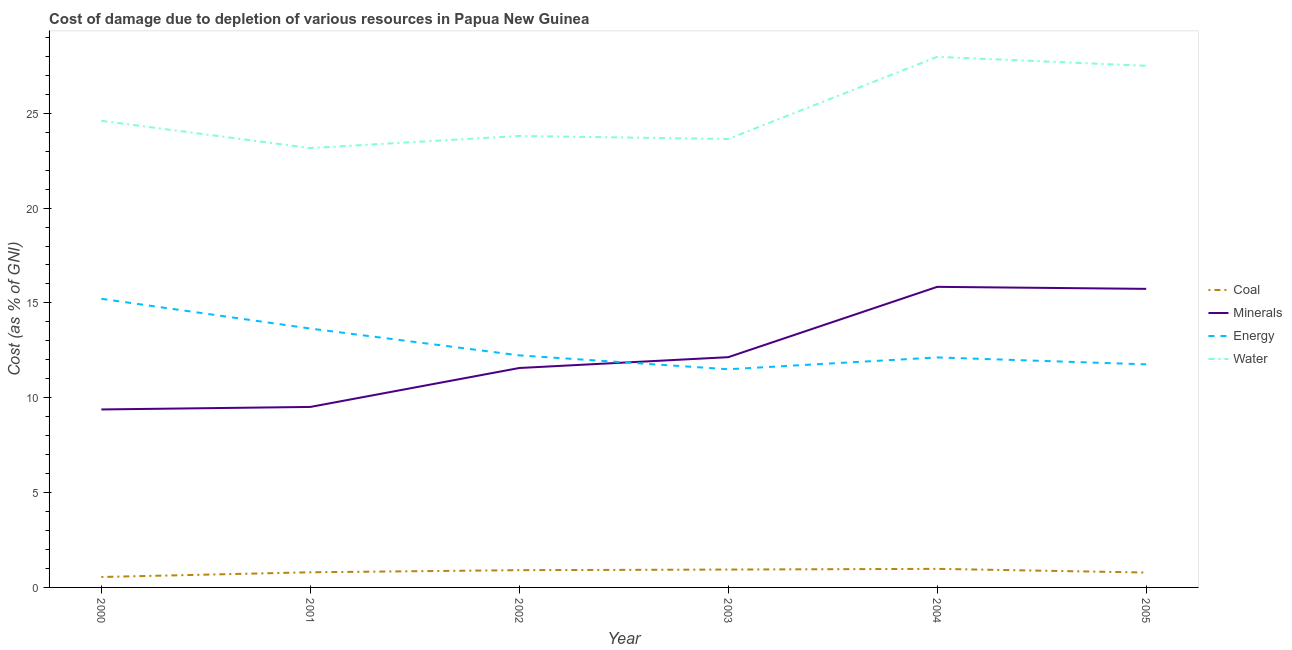How many different coloured lines are there?
Make the answer very short. 4. Is the number of lines equal to the number of legend labels?
Make the answer very short. Yes. What is the cost of damage due to depletion of energy in 2002?
Your answer should be very brief. 12.23. Across all years, what is the maximum cost of damage due to depletion of energy?
Give a very brief answer. 15.22. Across all years, what is the minimum cost of damage due to depletion of minerals?
Your answer should be compact. 9.38. In which year was the cost of damage due to depletion of minerals maximum?
Offer a very short reply. 2004. What is the total cost of damage due to depletion of water in the graph?
Your response must be concise. 150.68. What is the difference between the cost of damage due to depletion of minerals in 2000 and that in 2003?
Offer a very short reply. -2.76. What is the difference between the cost of damage due to depletion of energy in 2002 and the cost of damage due to depletion of minerals in 2005?
Keep it short and to the point. -3.51. What is the average cost of damage due to depletion of coal per year?
Your answer should be compact. 0.83. In the year 2000, what is the difference between the cost of damage due to depletion of minerals and cost of damage due to depletion of water?
Keep it short and to the point. -15.22. In how many years, is the cost of damage due to depletion of coal greater than 28 %?
Give a very brief answer. 0. What is the ratio of the cost of damage due to depletion of water in 2003 to that in 2004?
Keep it short and to the point. 0.85. Is the cost of damage due to depletion of minerals in 2002 less than that in 2004?
Your answer should be compact. Yes. What is the difference between the highest and the second highest cost of damage due to depletion of energy?
Make the answer very short. 1.57. What is the difference between the highest and the lowest cost of damage due to depletion of energy?
Make the answer very short. 3.71. Is it the case that in every year, the sum of the cost of damage due to depletion of coal and cost of damage due to depletion of minerals is greater than the sum of cost of damage due to depletion of energy and cost of damage due to depletion of water?
Provide a short and direct response. Yes. Does the cost of damage due to depletion of minerals monotonically increase over the years?
Provide a succinct answer. No. How many lines are there?
Your response must be concise. 4. What is the difference between two consecutive major ticks on the Y-axis?
Give a very brief answer. 5. Are the values on the major ticks of Y-axis written in scientific E-notation?
Make the answer very short. No. Does the graph contain any zero values?
Ensure brevity in your answer.  No. Where does the legend appear in the graph?
Offer a terse response. Center right. How many legend labels are there?
Offer a very short reply. 4. How are the legend labels stacked?
Your answer should be very brief. Vertical. What is the title of the graph?
Offer a terse response. Cost of damage due to depletion of various resources in Papua New Guinea . Does "Public resource use" appear as one of the legend labels in the graph?
Provide a succinct answer. No. What is the label or title of the Y-axis?
Give a very brief answer. Cost (as % of GNI). What is the Cost (as % of GNI) in Coal in 2000?
Provide a succinct answer. 0.55. What is the Cost (as % of GNI) of Minerals in 2000?
Your answer should be compact. 9.38. What is the Cost (as % of GNI) of Energy in 2000?
Give a very brief answer. 15.22. What is the Cost (as % of GNI) of Water in 2000?
Offer a very short reply. 24.6. What is the Cost (as % of GNI) in Coal in 2001?
Give a very brief answer. 0.8. What is the Cost (as % of GNI) in Minerals in 2001?
Give a very brief answer. 9.52. What is the Cost (as % of GNI) of Energy in 2001?
Keep it short and to the point. 13.65. What is the Cost (as % of GNI) of Water in 2001?
Your answer should be very brief. 23.16. What is the Cost (as % of GNI) in Coal in 2002?
Provide a short and direct response. 0.91. What is the Cost (as % of GNI) of Minerals in 2002?
Offer a terse response. 11.57. What is the Cost (as % of GNI) in Energy in 2002?
Ensure brevity in your answer.  12.23. What is the Cost (as % of GNI) in Water in 2002?
Your answer should be very brief. 23.8. What is the Cost (as % of GNI) in Coal in 2003?
Your response must be concise. 0.94. What is the Cost (as % of GNI) of Minerals in 2003?
Provide a succinct answer. 12.14. What is the Cost (as % of GNI) of Energy in 2003?
Ensure brevity in your answer.  11.5. What is the Cost (as % of GNI) of Water in 2003?
Make the answer very short. 23.64. What is the Cost (as % of GNI) in Coal in 2004?
Make the answer very short. 0.98. What is the Cost (as % of GNI) of Minerals in 2004?
Your response must be concise. 15.85. What is the Cost (as % of GNI) in Energy in 2004?
Keep it short and to the point. 12.13. What is the Cost (as % of GNI) in Water in 2004?
Your answer should be compact. 27.97. What is the Cost (as % of GNI) in Coal in 2005?
Your response must be concise. 0.79. What is the Cost (as % of GNI) of Minerals in 2005?
Offer a terse response. 15.74. What is the Cost (as % of GNI) of Energy in 2005?
Your answer should be compact. 11.76. What is the Cost (as % of GNI) of Water in 2005?
Provide a succinct answer. 27.5. Across all years, what is the maximum Cost (as % of GNI) in Coal?
Your response must be concise. 0.98. Across all years, what is the maximum Cost (as % of GNI) in Minerals?
Offer a terse response. 15.85. Across all years, what is the maximum Cost (as % of GNI) of Energy?
Your response must be concise. 15.22. Across all years, what is the maximum Cost (as % of GNI) in Water?
Your response must be concise. 27.97. Across all years, what is the minimum Cost (as % of GNI) in Coal?
Your answer should be compact. 0.55. Across all years, what is the minimum Cost (as % of GNI) in Minerals?
Offer a very short reply. 9.38. Across all years, what is the minimum Cost (as % of GNI) of Energy?
Provide a succinct answer. 11.5. Across all years, what is the minimum Cost (as % of GNI) of Water?
Provide a succinct answer. 23.16. What is the total Cost (as % of GNI) of Coal in the graph?
Make the answer very short. 4.97. What is the total Cost (as % of GNI) of Minerals in the graph?
Offer a very short reply. 74.19. What is the total Cost (as % of GNI) in Energy in the graph?
Ensure brevity in your answer.  76.49. What is the total Cost (as % of GNI) of Water in the graph?
Give a very brief answer. 150.68. What is the difference between the Cost (as % of GNI) of Coal in 2000 and that in 2001?
Make the answer very short. -0.25. What is the difference between the Cost (as % of GNI) in Minerals in 2000 and that in 2001?
Ensure brevity in your answer.  -0.13. What is the difference between the Cost (as % of GNI) of Energy in 2000 and that in 2001?
Your answer should be very brief. 1.57. What is the difference between the Cost (as % of GNI) of Water in 2000 and that in 2001?
Make the answer very short. 1.44. What is the difference between the Cost (as % of GNI) in Coal in 2000 and that in 2002?
Provide a succinct answer. -0.36. What is the difference between the Cost (as % of GNI) in Minerals in 2000 and that in 2002?
Ensure brevity in your answer.  -2.19. What is the difference between the Cost (as % of GNI) in Energy in 2000 and that in 2002?
Provide a succinct answer. 2.98. What is the difference between the Cost (as % of GNI) in Water in 2000 and that in 2002?
Give a very brief answer. 0.8. What is the difference between the Cost (as % of GNI) of Coal in 2000 and that in 2003?
Offer a very short reply. -0.39. What is the difference between the Cost (as % of GNI) of Minerals in 2000 and that in 2003?
Give a very brief answer. -2.76. What is the difference between the Cost (as % of GNI) in Energy in 2000 and that in 2003?
Ensure brevity in your answer.  3.71. What is the difference between the Cost (as % of GNI) of Water in 2000 and that in 2003?
Offer a terse response. 0.96. What is the difference between the Cost (as % of GNI) of Coal in 2000 and that in 2004?
Offer a terse response. -0.43. What is the difference between the Cost (as % of GNI) of Minerals in 2000 and that in 2004?
Your response must be concise. -6.46. What is the difference between the Cost (as % of GNI) of Energy in 2000 and that in 2004?
Provide a short and direct response. 3.09. What is the difference between the Cost (as % of GNI) of Water in 2000 and that in 2004?
Offer a very short reply. -3.37. What is the difference between the Cost (as % of GNI) of Coal in 2000 and that in 2005?
Your answer should be very brief. -0.24. What is the difference between the Cost (as % of GNI) of Minerals in 2000 and that in 2005?
Your answer should be very brief. -6.36. What is the difference between the Cost (as % of GNI) in Energy in 2000 and that in 2005?
Your answer should be compact. 3.46. What is the difference between the Cost (as % of GNI) in Water in 2000 and that in 2005?
Offer a very short reply. -2.9. What is the difference between the Cost (as % of GNI) in Coal in 2001 and that in 2002?
Offer a very short reply. -0.11. What is the difference between the Cost (as % of GNI) of Minerals in 2001 and that in 2002?
Give a very brief answer. -2.05. What is the difference between the Cost (as % of GNI) of Energy in 2001 and that in 2002?
Your answer should be very brief. 1.41. What is the difference between the Cost (as % of GNI) of Water in 2001 and that in 2002?
Keep it short and to the point. -0.64. What is the difference between the Cost (as % of GNI) in Coal in 2001 and that in 2003?
Offer a very short reply. -0.14. What is the difference between the Cost (as % of GNI) in Minerals in 2001 and that in 2003?
Keep it short and to the point. -2.62. What is the difference between the Cost (as % of GNI) in Energy in 2001 and that in 2003?
Give a very brief answer. 2.15. What is the difference between the Cost (as % of GNI) in Water in 2001 and that in 2003?
Your answer should be very brief. -0.48. What is the difference between the Cost (as % of GNI) in Coal in 2001 and that in 2004?
Your answer should be compact. -0.18. What is the difference between the Cost (as % of GNI) of Minerals in 2001 and that in 2004?
Give a very brief answer. -6.33. What is the difference between the Cost (as % of GNI) in Energy in 2001 and that in 2004?
Your response must be concise. 1.52. What is the difference between the Cost (as % of GNI) of Water in 2001 and that in 2004?
Offer a very short reply. -4.81. What is the difference between the Cost (as % of GNI) of Coal in 2001 and that in 2005?
Provide a short and direct response. 0.01. What is the difference between the Cost (as % of GNI) in Minerals in 2001 and that in 2005?
Provide a short and direct response. -6.23. What is the difference between the Cost (as % of GNI) in Energy in 2001 and that in 2005?
Offer a terse response. 1.89. What is the difference between the Cost (as % of GNI) of Water in 2001 and that in 2005?
Offer a very short reply. -4.34. What is the difference between the Cost (as % of GNI) in Coal in 2002 and that in 2003?
Provide a short and direct response. -0.03. What is the difference between the Cost (as % of GNI) in Minerals in 2002 and that in 2003?
Your answer should be compact. -0.57. What is the difference between the Cost (as % of GNI) of Energy in 2002 and that in 2003?
Ensure brevity in your answer.  0.73. What is the difference between the Cost (as % of GNI) of Water in 2002 and that in 2003?
Provide a short and direct response. 0.16. What is the difference between the Cost (as % of GNI) in Coal in 2002 and that in 2004?
Ensure brevity in your answer.  -0.07. What is the difference between the Cost (as % of GNI) of Minerals in 2002 and that in 2004?
Provide a succinct answer. -4.28. What is the difference between the Cost (as % of GNI) of Energy in 2002 and that in 2004?
Give a very brief answer. 0.11. What is the difference between the Cost (as % of GNI) of Water in 2002 and that in 2004?
Make the answer very short. -4.17. What is the difference between the Cost (as % of GNI) in Coal in 2002 and that in 2005?
Your answer should be compact. 0.13. What is the difference between the Cost (as % of GNI) in Minerals in 2002 and that in 2005?
Offer a terse response. -4.17. What is the difference between the Cost (as % of GNI) in Energy in 2002 and that in 2005?
Your answer should be very brief. 0.47. What is the difference between the Cost (as % of GNI) in Water in 2002 and that in 2005?
Keep it short and to the point. -3.7. What is the difference between the Cost (as % of GNI) of Coal in 2003 and that in 2004?
Offer a terse response. -0.04. What is the difference between the Cost (as % of GNI) of Minerals in 2003 and that in 2004?
Ensure brevity in your answer.  -3.71. What is the difference between the Cost (as % of GNI) of Energy in 2003 and that in 2004?
Make the answer very short. -0.62. What is the difference between the Cost (as % of GNI) of Water in 2003 and that in 2004?
Your answer should be very brief. -4.33. What is the difference between the Cost (as % of GNI) of Coal in 2003 and that in 2005?
Your answer should be very brief. 0.16. What is the difference between the Cost (as % of GNI) of Minerals in 2003 and that in 2005?
Your answer should be very brief. -3.6. What is the difference between the Cost (as % of GNI) of Energy in 2003 and that in 2005?
Your response must be concise. -0.26. What is the difference between the Cost (as % of GNI) of Water in 2003 and that in 2005?
Provide a short and direct response. -3.86. What is the difference between the Cost (as % of GNI) in Coal in 2004 and that in 2005?
Provide a succinct answer. 0.19. What is the difference between the Cost (as % of GNI) of Minerals in 2004 and that in 2005?
Ensure brevity in your answer.  0.11. What is the difference between the Cost (as % of GNI) of Energy in 2004 and that in 2005?
Offer a terse response. 0.37. What is the difference between the Cost (as % of GNI) of Water in 2004 and that in 2005?
Provide a short and direct response. 0.47. What is the difference between the Cost (as % of GNI) of Coal in 2000 and the Cost (as % of GNI) of Minerals in 2001?
Ensure brevity in your answer.  -8.97. What is the difference between the Cost (as % of GNI) in Coal in 2000 and the Cost (as % of GNI) in Energy in 2001?
Your response must be concise. -13.1. What is the difference between the Cost (as % of GNI) of Coal in 2000 and the Cost (as % of GNI) of Water in 2001?
Provide a succinct answer. -22.61. What is the difference between the Cost (as % of GNI) of Minerals in 2000 and the Cost (as % of GNI) of Energy in 2001?
Your answer should be compact. -4.27. What is the difference between the Cost (as % of GNI) in Minerals in 2000 and the Cost (as % of GNI) in Water in 2001?
Keep it short and to the point. -13.78. What is the difference between the Cost (as % of GNI) of Energy in 2000 and the Cost (as % of GNI) of Water in 2001?
Make the answer very short. -7.95. What is the difference between the Cost (as % of GNI) in Coal in 2000 and the Cost (as % of GNI) in Minerals in 2002?
Give a very brief answer. -11.02. What is the difference between the Cost (as % of GNI) of Coal in 2000 and the Cost (as % of GNI) of Energy in 2002?
Your answer should be very brief. -11.68. What is the difference between the Cost (as % of GNI) of Coal in 2000 and the Cost (as % of GNI) of Water in 2002?
Make the answer very short. -23.25. What is the difference between the Cost (as % of GNI) in Minerals in 2000 and the Cost (as % of GNI) in Energy in 2002?
Make the answer very short. -2.85. What is the difference between the Cost (as % of GNI) in Minerals in 2000 and the Cost (as % of GNI) in Water in 2002?
Give a very brief answer. -14.42. What is the difference between the Cost (as % of GNI) of Energy in 2000 and the Cost (as % of GNI) of Water in 2002?
Offer a terse response. -8.59. What is the difference between the Cost (as % of GNI) in Coal in 2000 and the Cost (as % of GNI) in Minerals in 2003?
Offer a terse response. -11.59. What is the difference between the Cost (as % of GNI) of Coal in 2000 and the Cost (as % of GNI) of Energy in 2003?
Your response must be concise. -10.95. What is the difference between the Cost (as % of GNI) in Coal in 2000 and the Cost (as % of GNI) in Water in 2003?
Provide a succinct answer. -23.09. What is the difference between the Cost (as % of GNI) of Minerals in 2000 and the Cost (as % of GNI) of Energy in 2003?
Offer a terse response. -2.12. What is the difference between the Cost (as % of GNI) in Minerals in 2000 and the Cost (as % of GNI) in Water in 2003?
Offer a terse response. -14.26. What is the difference between the Cost (as % of GNI) in Energy in 2000 and the Cost (as % of GNI) in Water in 2003?
Keep it short and to the point. -8.42. What is the difference between the Cost (as % of GNI) in Coal in 2000 and the Cost (as % of GNI) in Minerals in 2004?
Your response must be concise. -15.3. What is the difference between the Cost (as % of GNI) of Coal in 2000 and the Cost (as % of GNI) of Energy in 2004?
Your response must be concise. -11.58. What is the difference between the Cost (as % of GNI) in Coal in 2000 and the Cost (as % of GNI) in Water in 2004?
Your answer should be compact. -27.42. What is the difference between the Cost (as % of GNI) in Minerals in 2000 and the Cost (as % of GNI) in Energy in 2004?
Offer a very short reply. -2.74. What is the difference between the Cost (as % of GNI) in Minerals in 2000 and the Cost (as % of GNI) in Water in 2004?
Make the answer very short. -18.59. What is the difference between the Cost (as % of GNI) of Energy in 2000 and the Cost (as % of GNI) of Water in 2004?
Ensure brevity in your answer.  -12.76. What is the difference between the Cost (as % of GNI) in Coal in 2000 and the Cost (as % of GNI) in Minerals in 2005?
Ensure brevity in your answer.  -15.19. What is the difference between the Cost (as % of GNI) of Coal in 2000 and the Cost (as % of GNI) of Energy in 2005?
Ensure brevity in your answer.  -11.21. What is the difference between the Cost (as % of GNI) in Coal in 2000 and the Cost (as % of GNI) in Water in 2005?
Provide a succinct answer. -26.95. What is the difference between the Cost (as % of GNI) of Minerals in 2000 and the Cost (as % of GNI) of Energy in 2005?
Provide a succinct answer. -2.38. What is the difference between the Cost (as % of GNI) of Minerals in 2000 and the Cost (as % of GNI) of Water in 2005?
Your answer should be very brief. -18.12. What is the difference between the Cost (as % of GNI) in Energy in 2000 and the Cost (as % of GNI) in Water in 2005?
Give a very brief answer. -12.28. What is the difference between the Cost (as % of GNI) in Coal in 2001 and the Cost (as % of GNI) in Minerals in 2002?
Your response must be concise. -10.77. What is the difference between the Cost (as % of GNI) in Coal in 2001 and the Cost (as % of GNI) in Energy in 2002?
Provide a succinct answer. -11.44. What is the difference between the Cost (as % of GNI) of Coal in 2001 and the Cost (as % of GNI) of Water in 2002?
Provide a succinct answer. -23. What is the difference between the Cost (as % of GNI) of Minerals in 2001 and the Cost (as % of GNI) of Energy in 2002?
Provide a short and direct response. -2.72. What is the difference between the Cost (as % of GNI) of Minerals in 2001 and the Cost (as % of GNI) of Water in 2002?
Offer a very short reply. -14.29. What is the difference between the Cost (as % of GNI) in Energy in 2001 and the Cost (as % of GNI) in Water in 2002?
Your answer should be very brief. -10.15. What is the difference between the Cost (as % of GNI) of Coal in 2001 and the Cost (as % of GNI) of Minerals in 2003?
Your answer should be compact. -11.34. What is the difference between the Cost (as % of GNI) in Coal in 2001 and the Cost (as % of GNI) in Energy in 2003?
Provide a short and direct response. -10.7. What is the difference between the Cost (as % of GNI) in Coal in 2001 and the Cost (as % of GNI) in Water in 2003?
Ensure brevity in your answer.  -22.84. What is the difference between the Cost (as % of GNI) of Minerals in 2001 and the Cost (as % of GNI) of Energy in 2003?
Give a very brief answer. -1.99. What is the difference between the Cost (as % of GNI) of Minerals in 2001 and the Cost (as % of GNI) of Water in 2003?
Your answer should be very brief. -14.13. What is the difference between the Cost (as % of GNI) of Energy in 2001 and the Cost (as % of GNI) of Water in 2003?
Provide a succinct answer. -9.99. What is the difference between the Cost (as % of GNI) of Coal in 2001 and the Cost (as % of GNI) of Minerals in 2004?
Offer a terse response. -15.05. What is the difference between the Cost (as % of GNI) in Coal in 2001 and the Cost (as % of GNI) in Energy in 2004?
Provide a succinct answer. -11.33. What is the difference between the Cost (as % of GNI) in Coal in 2001 and the Cost (as % of GNI) in Water in 2004?
Provide a succinct answer. -27.18. What is the difference between the Cost (as % of GNI) in Minerals in 2001 and the Cost (as % of GNI) in Energy in 2004?
Give a very brief answer. -2.61. What is the difference between the Cost (as % of GNI) of Minerals in 2001 and the Cost (as % of GNI) of Water in 2004?
Your answer should be compact. -18.46. What is the difference between the Cost (as % of GNI) in Energy in 2001 and the Cost (as % of GNI) in Water in 2004?
Keep it short and to the point. -14.33. What is the difference between the Cost (as % of GNI) in Coal in 2001 and the Cost (as % of GNI) in Minerals in 2005?
Offer a very short reply. -14.94. What is the difference between the Cost (as % of GNI) in Coal in 2001 and the Cost (as % of GNI) in Energy in 2005?
Provide a short and direct response. -10.96. What is the difference between the Cost (as % of GNI) in Coal in 2001 and the Cost (as % of GNI) in Water in 2005?
Keep it short and to the point. -26.7. What is the difference between the Cost (as % of GNI) of Minerals in 2001 and the Cost (as % of GNI) of Energy in 2005?
Keep it short and to the point. -2.24. What is the difference between the Cost (as % of GNI) in Minerals in 2001 and the Cost (as % of GNI) in Water in 2005?
Offer a terse response. -17.99. What is the difference between the Cost (as % of GNI) in Energy in 2001 and the Cost (as % of GNI) in Water in 2005?
Keep it short and to the point. -13.85. What is the difference between the Cost (as % of GNI) in Coal in 2002 and the Cost (as % of GNI) in Minerals in 2003?
Provide a short and direct response. -11.23. What is the difference between the Cost (as % of GNI) of Coal in 2002 and the Cost (as % of GNI) of Energy in 2003?
Your answer should be compact. -10.59. What is the difference between the Cost (as % of GNI) of Coal in 2002 and the Cost (as % of GNI) of Water in 2003?
Offer a very short reply. -22.73. What is the difference between the Cost (as % of GNI) in Minerals in 2002 and the Cost (as % of GNI) in Energy in 2003?
Offer a very short reply. 0.07. What is the difference between the Cost (as % of GNI) in Minerals in 2002 and the Cost (as % of GNI) in Water in 2003?
Give a very brief answer. -12.07. What is the difference between the Cost (as % of GNI) in Energy in 2002 and the Cost (as % of GNI) in Water in 2003?
Offer a very short reply. -11.41. What is the difference between the Cost (as % of GNI) of Coal in 2002 and the Cost (as % of GNI) of Minerals in 2004?
Provide a succinct answer. -14.94. What is the difference between the Cost (as % of GNI) of Coal in 2002 and the Cost (as % of GNI) of Energy in 2004?
Keep it short and to the point. -11.22. What is the difference between the Cost (as % of GNI) of Coal in 2002 and the Cost (as % of GNI) of Water in 2004?
Make the answer very short. -27.06. What is the difference between the Cost (as % of GNI) of Minerals in 2002 and the Cost (as % of GNI) of Energy in 2004?
Provide a succinct answer. -0.56. What is the difference between the Cost (as % of GNI) in Minerals in 2002 and the Cost (as % of GNI) in Water in 2004?
Provide a short and direct response. -16.41. What is the difference between the Cost (as % of GNI) of Energy in 2002 and the Cost (as % of GNI) of Water in 2004?
Offer a terse response. -15.74. What is the difference between the Cost (as % of GNI) in Coal in 2002 and the Cost (as % of GNI) in Minerals in 2005?
Provide a succinct answer. -14.83. What is the difference between the Cost (as % of GNI) in Coal in 2002 and the Cost (as % of GNI) in Energy in 2005?
Offer a very short reply. -10.85. What is the difference between the Cost (as % of GNI) in Coal in 2002 and the Cost (as % of GNI) in Water in 2005?
Provide a short and direct response. -26.59. What is the difference between the Cost (as % of GNI) of Minerals in 2002 and the Cost (as % of GNI) of Energy in 2005?
Ensure brevity in your answer.  -0.19. What is the difference between the Cost (as % of GNI) of Minerals in 2002 and the Cost (as % of GNI) of Water in 2005?
Your response must be concise. -15.93. What is the difference between the Cost (as % of GNI) in Energy in 2002 and the Cost (as % of GNI) in Water in 2005?
Ensure brevity in your answer.  -15.27. What is the difference between the Cost (as % of GNI) in Coal in 2003 and the Cost (as % of GNI) in Minerals in 2004?
Your answer should be compact. -14.91. What is the difference between the Cost (as % of GNI) in Coal in 2003 and the Cost (as % of GNI) in Energy in 2004?
Your answer should be compact. -11.18. What is the difference between the Cost (as % of GNI) in Coal in 2003 and the Cost (as % of GNI) in Water in 2004?
Make the answer very short. -27.03. What is the difference between the Cost (as % of GNI) in Minerals in 2003 and the Cost (as % of GNI) in Energy in 2004?
Your answer should be compact. 0.01. What is the difference between the Cost (as % of GNI) in Minerals in 2003 and the Cost (as % of GNI) in Water in 2004?
Make the answer very short. -15.83. What is the difference between the Cost (as % of GNI) in Energy in 2003 and the Cost (as % of GNI) in Water in 2004?
Your answer should be very brief. -16.47. What is the difference between the Cost (as % of GNI) of Coal in 2003 and the Cost (as % of GNI) of Minerals in 2005?
Your answer should be compact. -14.8. What is the difference between the Cost (as % of GNI) in Coal in 2003 and the Cost (as % of GNI) in Energy in 2005?
Make the answer very short. -10.82. What is the difference between the Cost (as % of GNI) in Coal in 2003 and the Cost (as % of GNI) in Water in 2005?
Provide a succinct answer. -26.56. What is the difference between the Cost (as % of GNI) in Minerals in 2003 and the Cost (as % of GNI) in Energy in 2005?
Give a very brief answer. 0.38. What is the difference between the Cost (as % of GNI) in Minerals in 2003 and the Cost (as % of GNI) in Water in 2005?
Provide a succinct answer. -15.36. What is the difference between the Cost (as % of GNI) of Energy in 2003 and the Cost (as % of GNI) of Water in 2005?
Your answer should be very brief. -16. What is the difference between the Cost (as % of GNI) in Coal in 2004 and the Cost (as % of GNI) in Minerals in 2005?
Ensure brevity in your answer.  -14.76. What is the difference between the Cost (as % of GNI) of Coal in 2004 and the Cost (as % of GNI) of Energy in 2005?
Your answer should be compact. -10.78. What is the difference between the Cost (as % of GNI) in Coal in 2004 and the Cost (as % of GNI) in Water in 2005?
Offer a terse response. -26.52. What is the difference between the Cost (as % of GNI) in Minerals in 2004 and the Cost (as % of GNI) in Energy in 2005?
Offer a very short reply. 4.09. What is the difference between the Cost (as % of GNI) of Minerals in 2004 and the Cost (as % of GNI) of Water in 2005?
Give a very brief answer. -11.65. What is the difference between the Cost (as % of GNI) of Energy in 2004 and the Cost (as % of GNI) of Water in 2005?
Provide a succinct answer. -15.37. What is the average Cost (as % of GNI) of Coal per year?
Give a very brief answer. 0.83. What is the average Cost (as % of GNI) in Minerals per year?
Your answer should be very brief. 12.37. What is the average Cost (as % of GNI) of Energy per year?
Provide a succinct answer. 12.75. What is the average Cost (as % of GNI) of Water per year?
Ensure brevity in your answer.  25.11. In the year 2000, what is the difference between the Cost (as % of GNI) of Coal and Cost (as % of GNI) of Minerals?
Provide a short and direct response. -8.83. In the year 2000, what is the difference between the Cost (as % of GNI) in Coal and Cost (as % of GNI) in Energy?
Your answer should be compact. -14.67. In the year 2000, what is the difference between the Cost (as % of GNI) of Coal and Cost (as % of GNI) of Water?
Your answer should be compact. -24.05. In the year 2000, what is the difference between the Cost (as % of GNI) in Minerals and Cost (as % of GNI) in Energy?
Offer a terse response. -5.83. In the year 2000, what is the difference between the Cost (as % of GNI) in Minerals and Cost (as % of GNI) in Water?
Offer a very short reply. -15.22. In the year 2000, what is the difference between the Cost (as % of GNI) of Energy and Cost (as % of GNI) of Water?
Make the answer very short. -9.38. In the year 2001, what is the difference between the Cost (as % of GNI) of Coal and Cost (as % of GNI) of Minerals?
Make the answer very short. -8.72. In the year 2001, what is the difference between the Cost (as % of GNI) of Coal and Cost (as % of GNI) of Energy?
Ensure brevity in your answer.  -12.85. In the year 2001, what is the difference between the Cost (as % of GNI) in Coal and Cost (as % of GNI) in Water?
Offer a very short reply. -22.37. In the year 2001, what is the difference between the Cost (as % of GNI) in Minerals and Cost (as % of GNI) in Energy?
Your answer should be very brief. -4.13. In the year 2001, what is the difference between the Cost (as % of GNI) of Minerals and Cost (as % of GNI) of Water?
Provide a succinct answer. -13.65. In the year 2001, what is the difference between the Cost (as % of GNI) in Energy and Cost (as % of GNI) in Water?
Your answer should be very brief. -9.52. In the year 2002, what is the difference between the Cost (as % of GNI) of Coal and Cost (as % of GNI) of Minerals?
Your answer should be compact. -10.66. In the year 2002, what is the difference between the Cost (as % of GNI) in Coal and Cost (as % of GNI) in Energy?
Make the answer very short. -11.32. In the year 2002, what is the difference between the Cost (as % of GNI) in Coal and Cost (as % of GNI) in Water?
Make the answer very short. -22.89. In the year 2002, what is the difference between the Cost (as % of GNI) in Minerals and Cost (as % of GNI) in Energy?
Your response must be concise. -0.67. In the year 2002, what is the difference between the Cost (as % of GNI) in Minerals and Cost (as % of GNI) in Water?
Provide a succinct answer. -12.23. In the year 2002, what is the difference between the Cost (as % of GNI) in Energy and Cost (as % of GNI) in Water?
Your response must be concise. -11.57. In the year 2003, what is the difference between the Cost (as % of GNI) of Coal and Cost (as % of GNI) of Minerals?
Your answer should be compact. -11.2. In the year 2003, what is the difference between the Cost (as % of GNI) of Coal and Cost (as % of GNI) of Energy?
Your answer should be very brief. -10.56. In the year 2003, what is the difference between the Cost (as % of GNI) in Coal and Cost (as % of GNI) in Water?
Your answer should be very brief. -22.7. In the year 2003, what is the difference between the Cost (as % of GNI) in Minerals and Cost (as % of GNI) in Energy?
Your response must be concise. 0.64. In the year 2003, what is the difference between the Cost (as % of GNI) of Minerals and Cost (as % of GNI) of Water?
Ensure brevity in your answer.  -11.5. In the year 2003, what is the difference between the Cost (as % of GNI) of Energy and Cost (as % of GNI) of Water?
Offer a terse response. -12.14. In the year 2004, what is the difference between the Cost (as % of GNI) of Coal and Cost (as % of GNI) of Minerals?
Offer a very short reply. -14.87. In the year 2004, what is the difference between the Cost (as % of GNI) of Coal and Cost (as % of GNI) of Energy?
Ensure brevity in your answer.  -11.15. In the year 2004, what is the difference between the Cost (as % of GNI) in Coal and Cost (as % of GNI) in Water?
Keep it short and to the point. -26.99. In the year 2004, what is the difference between the Cost (as % of GNI) in Minerals and Cost (as % of GNI) in Energy?
Your answer should be very brief. 3.72. In the year 2004, what is the difference between the Cost (as % of GNI) in Minerals and Cost (as % of GNI) in Water?
Make the answer very short. -12.13. In the year 2004, what is the difference between the Cost (as % of GNI) in Energy and Cost (as % of GNI) in Water?
Keep it short and to the point. -15.85. In the year 2005, what is the difference between the Cost (as % of GNI) in Coal and Cost (as % of GNI) in Minerals?
Offer a very short reply. -14.96. In the year 2005, what is the difference between the Cost (as % of GNI) in Coal and Cost (as % of GNI) in Energy?
Provide a short and direct response. -10.97. In the year 2005, what is the difference between the Cost (as % of GNI) of Coal and Cost (as % of GNI) of Water?
Your answer should be very brief. -26.72. In the year 2005, what is the difference between the Cost (as % of GNI) in Minerals and Cost (as % of GNI) in Energy?
Ensure brevity in your answer.  3.98. In the year 2005, what is the difference between the Cost (as % of GNI) of Minerals and Cost (as % of GNI) of Water?
Your answer should be compact. -11.76. In the year 2005, what is the difference between the Cost (as % of GNI) of Energy and Cost (as % of GNI) of Water?
Keep it short and to the point. -15.74. What is the ratio of the Cost (as % of GNI) in Coal in 2000 to that in 2001?
Offer a terse response. 0.69. What is the ratio of the Cost (as % of GNI) of Minerals in 2000 to that in 2001?
Your response must be concise. 0.99. What is the ratio of the Cost (as % of GNI) in Energy in 2000 to that in 2001?
Give a very brief answer. 1.11. What is the ratio of the Cost (as % of GNI) in Water in 2000 to that in 2001?
Make the answer very short. 1.06. What is the ratio of the Cost (as % of GNI) in Coal in 2000 to that in 2002?
Offer a very short reply. 0.6. What is the ratio of the Cost (as % of GNI) in Minerals in 2000 to that in 2002?
Make the answer very short. 0.81. What is the ratio of the Cost (as % of GNI) of Energy in 2000 to that in 2002?
Your answer should be very brief. 1.24. What is the ratio of the Cost (as % of GNI) of Water in 2000 to that in 2002?
Offer a terse response. 1.03. What is the ratio of the Cost (as % of GNI) of Coal in 2000 to that in 2003?
Make the answer very short. 0.58. What is the ratio of the Cost (as % of GNI) in Minerals in 2000 to that in 2003?
Your answer should be compact. 0.77. What is the ratio of the Cost (as % of GNI) in Energy in 2000 to that in 2003?
Give a very brief answer. 1.32. What is the ratio of the Cost (as % of GNI) in Water in 2000 to that in 2003?
Give a very brief answer. 1.04. What is the ratio of the Cost (as % of GNI) of Coal in 2000 to that in 2004?
Offer a very short reply. 0.56. What is the ratio of the Cost (as % of GNI) of Minerals in 2000 to that in 2004?
Ensure brevity in your answer.  0.59. What is the ratio of the Cost (as % of GNI) in Energy in 2000 to that in 2004?
Give a very brief answer. 1.25. What is the ratio of the Cost (as % of GNI) in Water in 2000 to that in 2004?
Keep it short and to the point. 0.88. What is the ratio of the Cost (as % of GNI) of Coal in 2000 to that in 2005?
Your response must be concise. 0.7. What is the ratio of the Cost (as % of GNI) in Minerals in 2000 to that in 2005?
Your answer should be compact. 0.6. What is the ratio of the Cost (as % of GNI) in Energy in 2000 to that in 2005?
Keep it short and to the point. 1.29. What is the ratio of the Cost (as % of GNI) of Water in 2000 to that in 2005?
Ensure brevity in your answer.  0.89. What is the ratio of the Cost (as % of GNI) of Coal in 2001 to that in 2002?
Provide a short and direct response. 0.88. What is the ratio of the Cost (as % of GNI) in Minerals in 2001 to that in 2002?
Give a very brief answer. 0.82. What is the ratio of the Cost (as % of GNI) of Energy in 2001 to that in 2002?
Your response must be concise. 1.12. What is the ratio of the Cost (as % of GNI) of Water in 2001 to that in 2002?
Offer a very short reply. 0.97. What is the ratio of the Cost (as % of GNI) in Coal in 2001 to that in 2003?
Your answer should be compact. 0.85. What is the ratio of the Cost (as % of GNI) in Minerals in 2001 to that in 2003?
Offer a very short reply. 0.78. What is the ratio of the Cost (as % of GNI) in Energy in 2001 to that in 2003?
Offer a terse response. 1.19. What is the ratio of the Cost (as % of GNI) of Water in 2001 to that in 2003?
Provide a short and direct response. 0.98. What is the ratio of the Cost (as % of GNI) of Coal in 2001 to that in 2004?
Provide a succinct answer. 0.82. What is the ratio of the Cost (as % of GNI) of Minerals in 2001 to that in 2004?
Give a very brief answer. 0.6. What is the ratio of the Cost (as % of GNI) in Energy in 2001 to that in 2004?
Your response must be concise. 1.13. What is the ratio of the Cost (as % of GNI) of Water in 2001 to that in 2004?
Make the answer very short. 0.83. What is the ratio of the Cost (as % of GNI) in Coal in 2001 to that in 2005?
Ensure brevity in your answer.  1.02. What is the ratio of the Cost (as % of GNI) in Minerals in 2001 to that in 2005?
Provide a succinct answer. 0.6. What is the ratio of the Cost (as % of GNI) in Energy in 2001 to that in 2005?
Make the answer very short. 1.16. What is the ratio of the Cost (as % of GNI) of Water in 2001 to that in 2005?
Give a very brief answer. 0.84. What is the ratio of the Cost (as % of GNI) in Coal in 2002 to that in 2003?
Your answer should be compact. 0.97. What is the ratio of the Cost (as % of GNI) of Minerals in 2002 to that in 2003?
Provide a short and direct response. 0.95. What is the ratio of the Cost (as % of GNI) in Energy in 2002 to that in 2003?
Keep it short and to the point. 1.06. What is the ratio of the Cost (as % of GNI) of Water in 2002 to that in 2003?
Provide a succinct answer. 1.01. What is the ratio of the Cost (as % of GNI) in Coal in 2002 to that in 2004?
Your response must be concise. 0.93. What is the ratio of the Cost (as % of GNI) of Minerals in 2002 to that in 2004?
Your response must be concise. 0.73. What is the ratio of the Cost (as % of GNI) of Energy in 2002 to that in 2004?
Your answer should be very brief. 1.01. What is the ratio of the Cost (as % of GNI) in Water in 2002 to that in 2004?
Your answer should be very brief. 0.85. What is the ratio of the Cost (as % of GNI) of Coal in 2002 to that in 2005?
Offer a terse response. 1.16. What is the ratio of the Cost (as % of GNI) of Minerals in 2002 to that in 2005?
Ensure brevity in your answer.  0.73. What is the ratio of the Cost (as % of GNI) in Energy in 2002 to that in 2005?
Provide a short and direct response. 1.04. What is the ratio of the Cost (as % of GNI) of Water in 2002 to that in 2005?
Keep it short and to the point. 0.87. What is the ratio of the Cost (as % of GNI) of Coal in 2003 to that in 2004?
Keep it short and to the point. 0.96. What is the ratio of the Cost (as % of GNI) of Minerals in 2003 to that in 2004?
Your answer should be compact. 0.77. What is the ratio of the Cost (as % of GNI) of Energy in 2003 to that in 2004?
Offer a very short reply. 0.95. What is the ratio of the Cost (as % of GNI) of Water in 2003 to that in 2004?
Offer a very short reply. 0.85. What is the ratio of the Cost (as % of GNI) in Coal in 2003 to that in 2005?
Provide a succinct answer. 1.2. What is the ratio of the Cost (as % of GNI) in Minerals in 2003 to that in 2005?
Give a very brief answer. 0.77. What is the ratio of the Cost (as % of GNI) of Energy in 2003 to that in 2005?
Provide a short and direct response. 0.98. What is the ratio of the Cost (as % of GNI) of Water in 2003 to that in 2005?
Keep it short and to the point. 0.86. What is the ratio of the Cost (as % of GNI) in Coal in 2004 to that in 2005?
Offer a terse response. 1.25. What is the ratio of the Cost (as % of GNI) of Minerals in 2004 to that in 2005?
Keep it short and to the point. 1.01. What is the ratio of the Cost (as % of GNI) in Energy in 2004 to that in 2005?
Give a very brief answer. 1.03. What is the ratio of the Cost (as % of GNI) in Water in 2004 to that in 2005?
Ensure brevity in your answer.  1.02. What is the difference between the highest and the second highest Cost (as % of GNI) of Coal?
Your answer should be very brief. 0.04. What is the difference between the highest and the second highest Cost (as % of GNI) of Minerals?
Provide a succinct answer. 0.11. What is the difference between the highest and the second highest Cost (as % of GNI) of Energy?
Offer a terse response. 1.57. What is the difference between the highest and the second highest Cost (as % of GNI) in Water?
Make the answer very short. 0.47. What is the difference between the highest and the lowest Cost (as % of GNI) of Coal?
Offer a very short reply. 0.43. What is the difference between the highest and the lowest Cost (as % of GNI) in Minerals?
Provide a short and direct response. 6.46. What is the difference between the highest and the lowest Cost (as % of GNI) of Energy?
Your answer should be very brief. 3.71. What is the difference between the highest and the lowest Cost (as % of GNI) in Water?
Offer a very short reply. 4.81. 